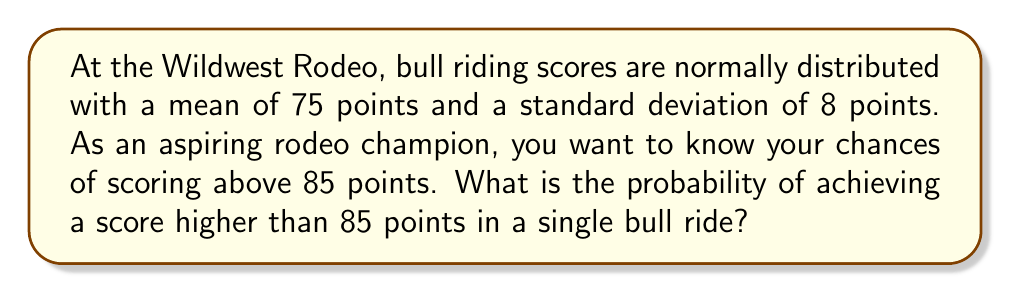Can you solve this math problem? Let's approach this step-by-step:

1) We're dealing with a normal distribution where:
   Mean (μ) = 75 points
   Standard deviation (σ) = 8 points

2) We want to find P(X > 85), where X is the bull riding score.

3) To solve this, we need to calculate the z-score for 85 points:

   $$z = \frac{x - \mu}{\sigma} = \frac{85 - 75}{8} = 1.25$$

4) Now, we need to find the area to the right of z = 1.25 on the standard normal distribution.

5) Using a standard normal table or calculator, we can find that:
   P(Z > 1.25) ≈ 0.1056

6) Therefore, the probability of scoring above 85 points is approximately 0.1056 or 10.56%.

This means that in any given bull ride, you have about a 10.56% chance of scoring above 85 points.
Answer: 0.1056 or 10.56% 